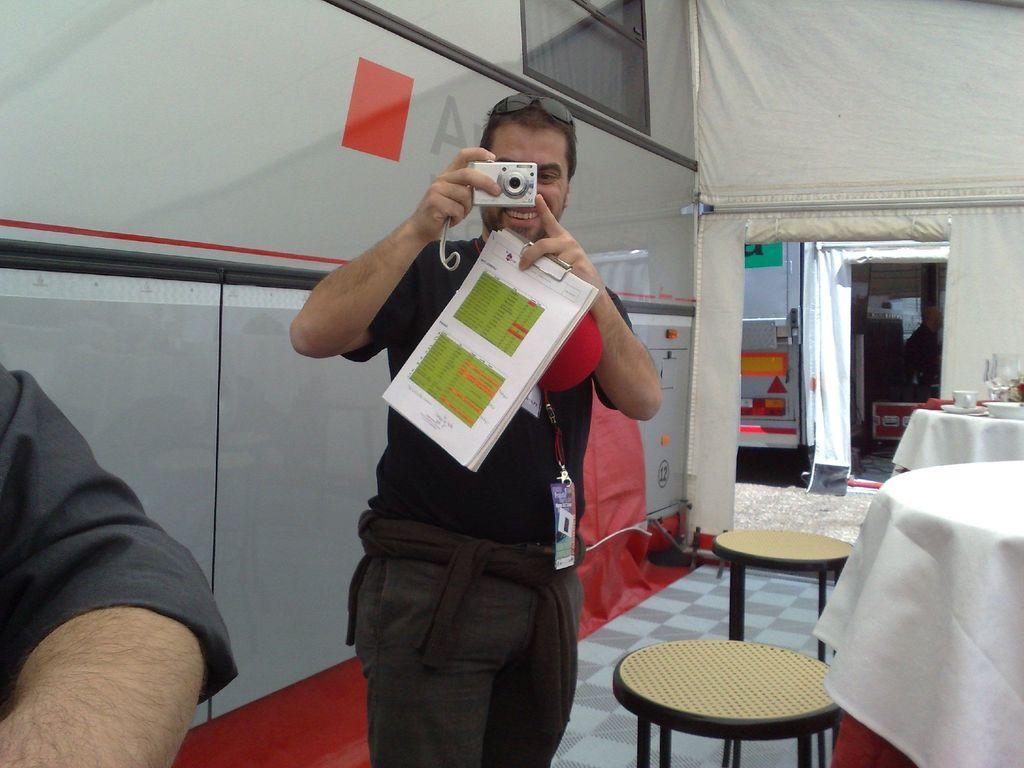How would you summarize this image in a sentence or two? In this image I see a man who is standing and holding a camera and a book in his hand, I can also see that he is smiling, beside to him I see a person's hand. In the background I see 2 stools and 2 tables. 